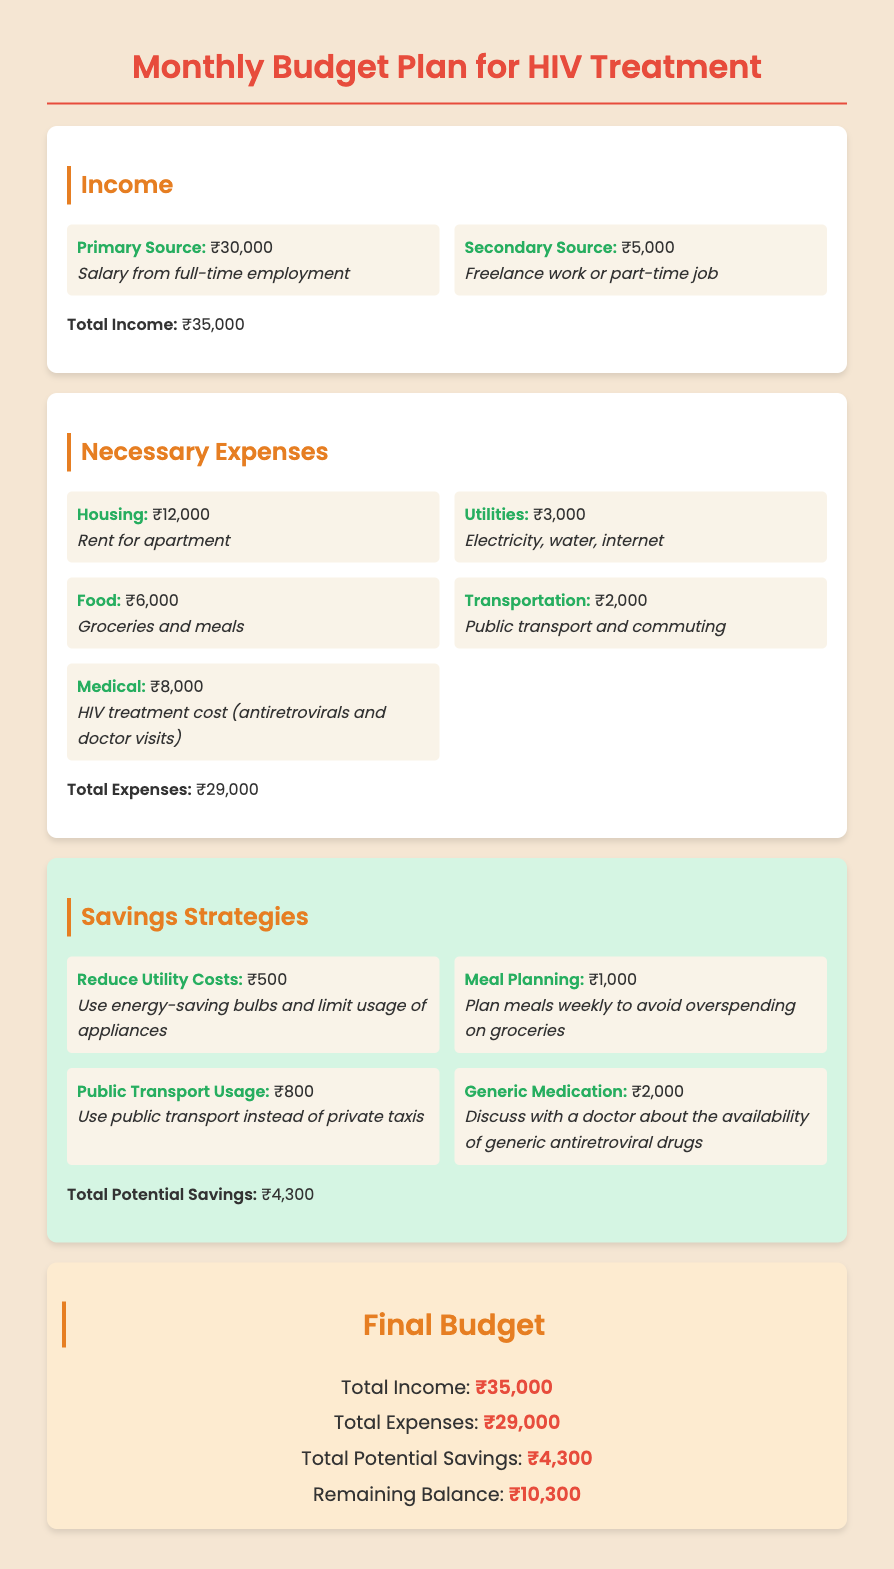What is the total income? The total income is the sum of the primary and secondary sources of income, which is ₹30,000 + ₹5,000.
Answer: ₹35,000 What is the cost of HIV treatment in the necessary expenses? The cost of HIV treatment is specifically stated under medical expenses in the document.
Answer: ₹8,000 How much can you potentially save by using public transport? The savings strategy specifies the amount that can be saved by using public transport instead of private taxis.
Answer: ₹800 What is the total potential savings? The total potential savings is listed at the end of the savings strategies section.
Answer: ₹4,300 What is the remaining balance after expenses? The remaining balance is calculated by subtracting total expenses from total income.
Answer: ₹10,300 